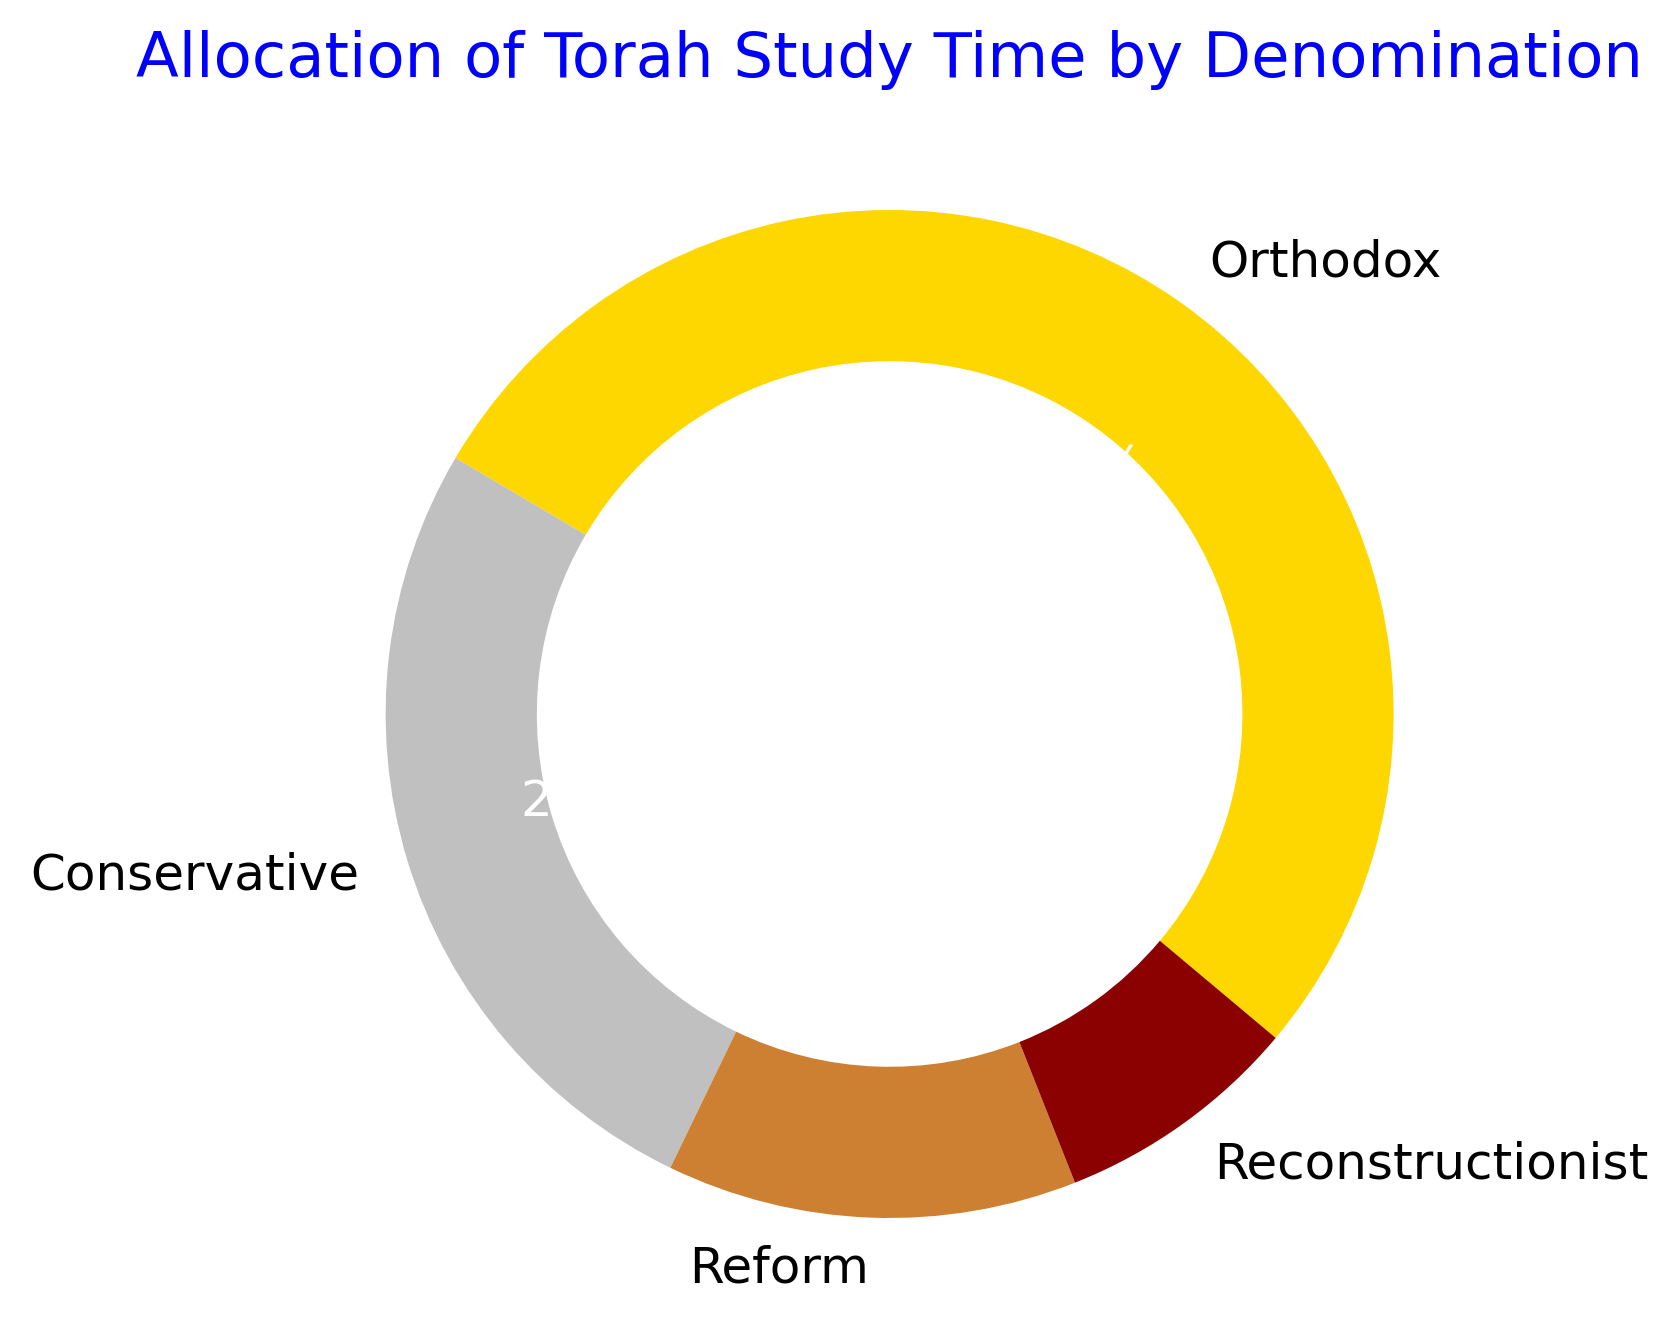What percentage of Torah study time is allocated by the Orthodox denomination? To find the percentage allocated by the Orthodox denomination, look at the corresponding section in the ring chart. The percentage is usually labeled inside the section.
Answer: 50.0% How many hours per week are spent on Torah study by non-Orthodox denominations? Add the hours of Torah study per week for Conservative, Reform, and Reconstructionist denominations. That's 10 (Conservative) + 5 (Reform) + 3 (Reconstructionist).
Answer: 18 Which denomination allocates the least amount of time to Torah study? By observing the ring chart, identify the smallest section, which corresponds to the denomination with the least allocated time.
Answer: Reconstructionist How does the Torah study time of the Conservative denomination compare to that of the Reform denomination? Compare the sizes of the sections in the ring chart labeled Conservative and Reform. The Conservative denomination allocates 10 hours, while the Reform allocates 5 hours per week.
Answer: Conservative allocates more What is the difference in Torah study time between Orthodox and Conservative denominations? Subtract the hours per week spent by the Conservative denomination (10) from the hours spent by the Orthodox (20).
Answer: 10 hours What fraction of Torah study time is dedicated by the Conservative and Reform denominations combined? Add the percentages of the Conservative and Reform denominations. In the ring chart, Conservative is 25.0% and Reform is 12.5%.
Answer: 37.5% Which denomination's section is represented in gold color? Examine the ring chart and identify the section displayed in gold. Typically, color indicators are provided in the legend or in the sections themselves.
Answer: Orthodox What is the sum of the Torah study times for Orthodox and Reconstructionist denominations? Add the hours per week for Orthodox (20) and Reconstructionist (3).
Answer: 23 hours What is the ratio of Torah study time between the Orthodox and Reform denominations? Divide the hours per week of the Orthodox (20) by the hours per week of the Reform (5).
Answer: 4:1 Comparing the Conservative and Reconstructionist denominations, which one spends more than double the hours per week on Torah study? Multiply the hours per week spent by the Reconstructionist denomination (3) by 2 to get 6. The Conservative denomination spends 10 hours per week, which is more than double.
Answer: Conservative 